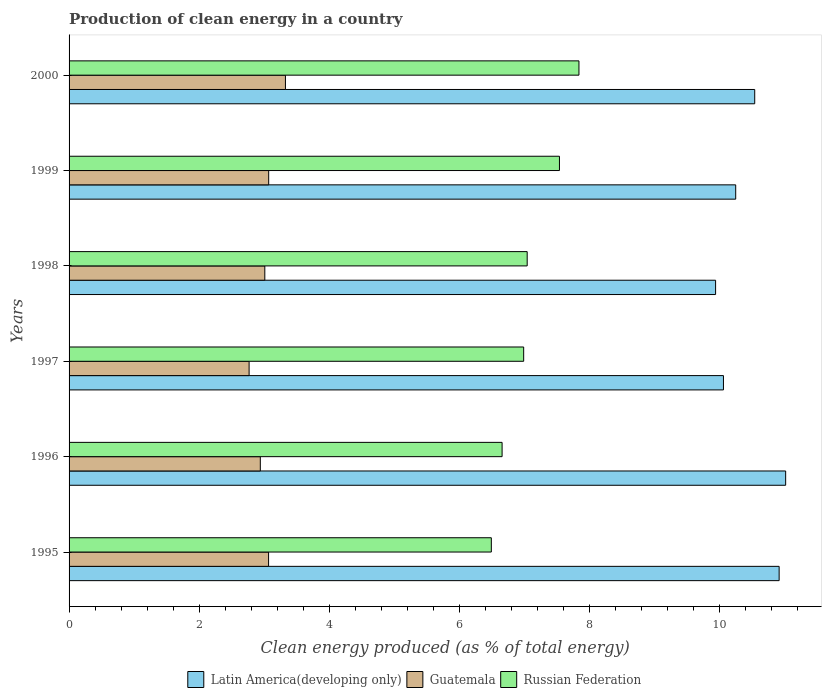How many different coloured bars are there?
Your answer should be very brief. 3. Are the number of bars per tick equal to the number of legend labels?
Make the answer very short. Yes. Are the number of bars on each tick of the Y-axis equal?
Provide a succinct answer. Yes. How many bars are there on the 4th tick from the top?
Keep it short and to the point. 3. In how many cases, is the number of bars for a given year not equal to the number of legend labels?
Your answer should be very brief. 0. What is the percentage of clean energy produced in Guatemala in 1998?
Give a very brief answer. 3.01. Across all years, what is the maximum percentage of clean energy produced in Russian Federation?
Your answer should be compact. 7.84. Across all years, what is the minimum percentage of clean energy produced in Latin America(developing only)?
Keep it short and to the point. 9.95. What is the total percentage of clean energy produced in Russian Federation in the graph?
Make the answer very short. 42.59. What is the difference between the percentage of clean energy produced in Russian Federation in 1996 and that in 2000?
Your answer should be compact. -1.18. What is the difference between the percentage of clean energy produced in Latin America(developing only) in 2000 and the percentage of clean energy produced in Russian Federation in 1995?
Make the answer very short. 4.05. What is the average percentage of clean energy produced in Russian Federation per year?
Make the answer very short. 7.1. In the year 1999, what is the difference between the percentage of clean energy produced in Latin America(developing only) and percentage of clean energy produced in Guatemala?
Make the answer very short. 7.19. In how many years, is the percentage of clean energy produced in Latin America(developing only) greater than 9.6 %?
Give a very brief answer. 6. What is the ratio of the percentage of clean energy produced in Russian Federation in 1998 to that in 2000?
Provide a short and direct response. 0.9. Is the percentage of clean energy produced in Guatemala in 1998 less than that in 1999?
Your answer should be very brief. Yes. What is the difference between the highest and the second highest percentage of clean energy produced in Latin America(developing only)?
Offer a terse response. 0.1. What is the difference between the highest and the lowest percentage of clean energy produced in Latin America(developing only)?
Your answer should be very brief. 1.08. What does the 1st bar from the top in 1997 represents?
Keep it short and to the point. Russian Federation. What does the 1st bar from the bottom in 1996 represents?
Your answer should be very brief. Latin America(developing only). Is it the case that in every year, the sum of the percentage of clean energy produced in Latin America(developing only) and percentage of clean energy produced in Guatemala is greater than the percentage of clean energy produced in Russian Federation?
Your response must be concise. Yes. How many bars are there?
Your answer should be compact. 18. Are all the bars in the graph horizontal?
Provide a succinct answer. Yes. Does the graph contain any zero values?
Your answer should be very brief. No. What is the title of the graph?
Your answer should be very brief. Production of clean energy in a country. What is the label or title of the X-axis?
Make the answer very short. Clean energy produced (as % of total energy). What is the Clean energy produced (as % of total energy) in Latin America(developing only) in 1995?
Provide a succinct answer. 10.92. What is the Clean energy produced (as % of total energy) in Guatemala in 1995?
Your response must be concise. 3.07. What is the Clean energy produced (as % of total energy) of Russian Federation in 1995?
Offer a very short reply. 6.5. What is the Clean energy produced (as % of total energy) of Latin America(developing only) in 1996?
Provide a short and direct response. 11.03. What is the Clean energy produced (as % of total energy) in Guatemala in 1996?
Your response must be concise. 2.94. What is the Clean energy produced (as % of total energy) in Russian Federation in 1996?
Give a very brief answer. 6.66. What is the Clean energy produced (as % of total energy) in Latin America(developing only) in 1997?
Your answer should be compact. 10.07. What is the Clean energy produced (as % of total energy) in Guatemala in 1997?
Provide a short and direct response. 2.77. What is the Clean energy produced (as % of total energy) in Russian Federation in 1997?
Ensure brevity in your answer.  6.99. What is the Clean energy produced (as % of total energy) in Latin America(developing only) in 1998?
Give a very brief answer. 9.95. What is the Clean energy produced (as % of total energy) of Guatemala in 1998?
Provide a succinct answer. 3.01. What is the Clean energy produced (as % of total energy) of Russian Federation in 1998?
Provide a short and direct response. 7.05. What is the Clean energy produced (as % of total energy) of Latin America(developing only) in 1999?
Keep it short and to the point. 10.26. What is the Clean energy produced (as % of total energy) of Guatemala in 1999?
Make the answer very short. 3.07. What is the Clean energy produced (as % of total energy) in Russian Federation in 1999?
Keep it short and to the point. 7.54. What is the Clean energy produced (as % of total energy) of Latin America(developing only) in 2000?
Provide a short and direct response. 10.55. What is the Clean energy produced (as % of total energy) in Guatemala in 2000?
Ensure brevity in your answer.  3.33. What is the Clean energy produced (as % of total energy) in Russian Federation in 2000?
Make the answer very short. 7.84. Across all years, what is the maximum Clean energy produced (as % of total energy) of Latin America(developing only)?
Your answer should be compact. 11.03. Across all years, what is the maximum Clean energy produced (as % of total energy) in Guatemala?
Make the answer very short. 3.33. Across all years, what is the maximum Clean energy produced (as % of total energy) of Russian Federation?
Keep it short and to the point. 7.84. Across all years, what is the minimum Clean energy produced (as % of total energy) in Latin America(developing only)?
Provide a short and direct response. 9.95. Across all years, what is the minimum Clean energy produced (as % of total energy) of Guatemala?
Your answer should be very brief. 2.77. Across all years, what is the minimum Clean energy produced (as % of total energy) in Russian Federation?
Provide a short and direct response. 6.5. What is the total Clean energy produced (as % of total energy) in Latin America(developing only) in the graph?
Keep it short and to the point. 62.77. What is the total Clean energy produced (as % of total energy) in Guatemala in the graph?
Your answer should be compact. 18.19. What is the total Clean energy produced (as % of total energy) in Russian Federation in the graph?
Give a very brief answer. 42.59. What is the difference between the Clean energy produced (as % of total energy) in Latin America(developing only) in 1995 and that in 1996?
Make the answer very short. -0.1. What is the difference between the Clean energy produced (as % of total energy) of Guatemala in 1995 and that in 1996?
Your answer should be very brief. 0.13. What is the difference between the Clean energy produced (as % of total energy) of Russian Federation in 1995 and that in 1996?
Make the answer very short. -0.17. What is the difference between the Clean energy produced (as % of total energy) in Latin America(developing only) in 1995 and that in 1997?
Keep it short and to the point. 0.86. What is the difference between the Clean energy produced (as % of total energy) in Guatemala in 1995 and that in 1997?
Provide a succinct answer. 0.3. What is the difference between the Clean energy produced (as % of total energy) of Russian Federation in 1995 and that in 1997?
Keep it short and to the point. -0.5. What is the difference between the Clean energy produced (as % of total energy) of Latin America(developing only) in 1995 and that in 1998?
Your response must be concise. 0.98. What is the difference between the Clean energy produced (as % of total energy) in Guatemala in 1995 and that in 1998?
Your answer should be compact. 0.06. What is the difference between the Clean energy produced (as % of total energy) in Russian Federation in 1995 and that in 1998?
Provide a succinct answer. -0.55. What is the difference between the Clean energy produced (as % of total energy) in Latin America(developing only) in 1995 and that in 1999?
Your answer should be very brief. 0.67. What is the difference between the Clean energy produced (as % of total energy) in Guatemala in 1995 and that in 1999?
Provide a succinct answer. -0. What is the difference between the Clean energy produced (as % of total energy) in Russian Federation in 1995 and that in 1999?
Keep it short and to the point. -1.05. What is the difference between the Clean energy produced (as % of total energy) of Latin America(developing only) in 1995 and that in 2000?
Keep it short and to the point. 0.38. What is the difference between the Clean energy produced (as % of total energy) of Guatemala in 1995 and that in 2000?
Ensure brevity in your answer.  -0.26. What is the difference between the Clean energy produced (as % of total energy) in Russian Federation in 1995 and that in 2000?
Offer a very short reply. -1.35. What is the difference between the Clean energy produced (as % of total energy) of Latin America(developing only) in 1996 and that in 1997?
Provide a succinct answer. 0.96. What is the difference between the Clean energy produced (as % of total energy) of Guatemala in 1996 and that in 1997?
Ensure brevity in your answer.  0.17. What is the difference between the Clean energy produced (as % of total energy) in Russian Federation in 1996 and that in 1997?
Offer a very short reply. -0.33. What is the difference between the Clean energy produced (as % of total energy) in Latin America(developing only) in 1996 and that in 1998?
Offer a very short reply. 1.08. What is the difference between the Clean energy produced (as % of total energy) in Guatemala in 1996 and that in 1998?
Offer a terse response. -0.07. What is the difference between the Clean energy produced (as % of total energy) in Russian Federation in 1996 and that in 1998?
Keep it short and to the point. -0.39. What is the difference between the Clean energy produced (as % of total energy) in Latin America(developing only) in 1996 and that in 1999?
Your response must be concise. 0.77. What is the difference between the Clean energy produced (as % of total energy) of Guatemala in 1996 and that in 1999?
Your answer should be very brief. -0.13. What is the difference between the Clean energy produced (as % of total energy) of Russian Federation in 1996 and that in 1999?
Offer a terse response. -0.88. What is the difference between the Clean energy produced (as % of total energy) of Latin America(developing only) in 1996 and that in 2000?
Make the answer very short. 0.48. What is the difference between the Clean energy produced (as % of total energy) of Guatemala in 1996 and that in 2000?
Ensure brevity in your answer.  -0.39. What is the difference between the Clean energy produced (as % of total energy) in Russian Federation in 1996 and that in 2000?
Your answer should be very brief. -1.18. What is the difference between the Clean energy produced (as % of total energy) of Latin America(developing only) in 1997 and that in 1998?
Your answer should be compact. 0.12. What is the difference between the Clean energy produced (as % of total energy) in Guatemala in 1997 and that in 1998?
Offer a terse response. -0.24. What is the difference between the Clean energy produced (as % of total energy) of Russian Federation in 1997 and that in 1998?
Offer a very short reply. -0.05. What is the difference between the Clean energy produced (as % of total energy) of Latin America(developing only) in 1997 and that in 1999?
Give a very brief answer. -0.19. What is the difference between the Clean energy produced (as % of total energy) in Guatemala in 1997 and that in 1999?
Make the answer very short. -0.3. What is the difference between the Clean energy produced (as % of total energy) in Russian Federation in 1997 and that in 1999?
Offer a very short reply. -0.55. What is the difference between the Clean energy produced (as % of total energy) in Latin America(developing only) in 1997 and that in 2000?
Offer a very short reply. -0.48. What is the difference between the Clean energy produced (as % of total energy) in Guatemala in 1997 and that in 2000?
Offer a very short reply. -0.56. What is the difference between the Clean energy produced (as % of total energy) in Russian Federation in 1997 and that in 2000?
Offer a terse response. -0.85. What is the difference between the Clean energy produced (as % of total energy) of Latin America(developing only) in 1998 and that in 1999?
Give a very brief answer. -0.31. What is the difference between the Clean energy produced (as % of total energy) in Guatemala in 1998 and that in 1999?
Provide a succinct answer. -0.06. What is the difference between the Clean energy produced (as % of total energy) in Russian Federation in 1998 and that in 1999?
Provide a short and direct response. -0.5. What is the difference between the Clean energy produced (as % of total energy) of Latin America(developing only) in 1998 and that in 2000?
Your answer should be very brief. -0.6. What is the difference between the Clean energy produced (as % of total energy) of Guatemala in 1998 and that in 2000?
Your answer should be compact. -0.32. What is the difference between the Clean energy produced (as % of total energy) of Russian Federation in 1998 and that in 2000?
Your response must be concise. -0.8. What is the difference between the Clean energy produced (as % of total energy) in Latin America(developing only) in 1999 and that in 2000?
Offer a terse response. -0.29. What is the difference between the Clean energy produced (as % of total energy) in Guatemala in 1999 and that in 2000?
Offer a terse response. -0.26. What is the difference between the Clean energy produced (as % of total energy) in Russian Federation in 1999 and that in 2000?
Provide a short and direct response. -0.3. What is the difference between the Clean energy produced (as % of total energy) of Latin America(developing only) in 1995 and the Clean energy produced (as % of total energy) of Guatemala in 1996?
Give a very brief answer. 7.98. What is the difference between the Clean energy produced (as % of total energy) in Latin America(developing only) in 1995 and the Clean energy produced (as % of total energy) in Russian Federation in 1996?
Keep it short and to the point. 4.26. What is the difference between the Clean energy produced (as % of total energy) of Guatemala in 1995 and the Clean energy produced (as % of total energy) of Russian Federation in 1996?
Keep it short and to the point. -3.59. What is the difference between the Clean energy produced (as % of total energy) of Latin America(developing only) in 1995 and the Clean energy produced (as % of total energy) of Guatemala in 1997?
Your response must be concise. 8.15. What is the difference between the Clean energy produced (as % of total energy) of Latin America(developing only) in 1995 and the Clean energy produced (as % of total energy) of Russian Federation in 1997?
Provide a succinct answer. 3.93. What is the difference between the Clean energy produced (as % of total energy) of Guatemala in 1995 and the Clean energy produced (as % of total energy) of Russian Federation in 1997?
Offer a terse response. -3.92. What is the difference between the Clean energy produced (as % of total energy) of Latin America(developing only) in 1995 and the Clean energy produced (as % of total energy) of Guatemala in 1998?
Provide a short and direct response. 7.91. What is the difference between the Clean energy produced (as % of total energy) of Latin America(developing only) in 1995 and the Clean energy produced (as % of total energy) of Russian Federation in 1998?
Ensure brevity in your answer.  3.88. What is the difference between the Clean energy produced (as % of total energy) of Guatemala in 1995 and the Clean energy produced (as % of total energy) of Russian Federation in 1998?
Your answer should be very brief. -3.98. What is the difference between the Clean energy produced (as % of total energy) of Latin America(developing only) in 1995 and the Clean energy produced (as % of total energy) of Guatemala in 1999?
Your answer should be compact. 7.85. What is the difference between the Clean energy produced (as % of total energy) in Latin America(developing only) in 1995 and the Clean energy produced (as % of total energy) in Russian Federation in 1999?
Offer a very short reply. 3.38. What is the difference between the Clean energy produced (as % of total energy) of Guatemala in 1995 and the Clean energy produced (as % of total energy) of Russian Federation in 1999?
Your answer should be compact. -4.48. What is the difference between the Clean energy produced (as % of total energy) in Latin America(developing only) in 1995 and the Clean energy produced (as % of total energy) in Guatemala in 2000?
Provide a short and direct response. 7.6. What is the difference between the Clean energy produced (as % of total energy) of Latin America(developing only) in 1995 and the Clean energy produced (as % of total energy) of Russian Federation in 2000?
Provide a succinct answer. 3.08. What is the difference between the Clean energy produced (as % of total energy) in Guatemala in 1995 and the Clean energy produced (as % of total energy) in Russian Federation in 2000?
Offer a terse response. -4.78. What is the difference between the Clean energy produced (as % of total energy) in Latin America(developing only) in 1996 and the Clean energy produced (as % of total energy) in Guatemala in 1997?
Ensure brevity in your answer.  8.26. What is the difference between the Clean energy produced (as % of total energy) of Latin America(developing only) in 1996 and the Clean energy produced (as % of total energy) of Russian Federation in 1997?
Your answer should be compact. 4.03. What is the difference between the Clean energy produced (as % of total energy) of Guatemala in 1996 and the Clean energy produced (as % of total energy) of Russian Federation in 1997?
Your answer should be very brief. -4.05. What is the difference between the Clean energy produced (as % of total energy) in Latin America(developing only) in 1996 and the Clean energy produced (as % of total energy) in Guatemala in 1998?
Offer a terse response. 8.01. What is the difference between the Clean energy produced (as % of total energy) in Latin America(developing only) in 1996 and the Clean energy produced (as % of total energy) in Russian Federation in 1998?
Provide a short and direct response. 3.98. What is the difference between the Clean energy produced (as % of total energy) in Guatemala in 1996 and the Clean energy produced (as % of total energy) in Russian Federation in 1998?
Give a very brief answer. -4.11. What is the difference between the Clean energy produced (as % of total energy) in Latin America(developing only) in 1996 and the Clean energy produced (as % of total energy) in Guatemala in 1999?
Keep it short and to the point. 7.95. What is the difference between the Clean energy produced (as % of total energy) in Latin America(developing only) in 1996 and the Clean energy produced (as % of total energy) in Russian Federation in 1999?
Offer a terse response. 3.48. What is the difference between the Clean energy produced (as % of total energy) in Guatemala in 1996 and the Clean energy produced (as % of total energy) in Russian Federation in 1999?
Give a very brief answer. -4.6. What is the difference between the Clean energy produced (as % of total energy) in Latin America(developing only) in 1996 and the Clean energy produced (as % of total energy) in Guatemala in 2000?
Offer a terse response. 7.7. What is the difference between the Clean energy produced (as % of total energy) of Latin America(developing only) in 1996 and the Clean energy produced (as % of total energy) of Russian Federation in 2000?
Ensure brevity in your answer.  3.18. What is the difference between the Clean energy produced (as % of total energy) in Guatemala in 1996 and the Clean energy produced (as % of total energy) in Russian Federation in 2000?
Offer a very short reply. -4.9. What is the difference between the Clean energy produced (as % of total energy) of Latin America(developing only) in 1997 and the Clean energy produced (as % of total energy) of Guatemala in 1998?
Give a very brief answer. 7.06. What is the difference between the Clean energy produced (as % of total energy) of Latin America(developing only) in 1997 and the Clean energy produced (as % of total energy) of Russian Federation in 1998?
Ensure brevity in your answer.  3.02. What is the difference between the Clean energy produced (as % of total energy) of Guatemala in 1997 and the Clean energy produced (as % of total energy) of Russian Federation in 1998?
Your answer should be compact. -4.28. What is the difference between the Clean energy produced (as % of total energy) in Latin America(developing only) in 1997 and the Clean energy produced (as % of total energy) in Guatemala in 1999?
Give a very brief answer. 7. What is the difference between the Clean energy produced (as % of total energy) of Latin America(developing only) in 1997 and the Clean energy produced (as % of total energy) of Russian Federation in 1999?
Give a very brief answer. 2.52. What is the difference between the Clean energy produced (as % of total energy) in Guatemala in 1997 and the Clean energy produced (as % of total energy) in Russian Federation in 1999?
Ensure brevity in your answer.  -4.77. What is the difference between the Clean energy produced (as % of total energy) in Latin America(developing only) in 1997 and the Clean energy produced (as % of total energy) in Guatemala in 2000?
Your answer should be compact. 6.74. What is the difference between the Clean energy produced (as % of total energy) in Latin America(developing only) in 1997 and the Clean energy produced (as % of total energy) in Russian Federation in 2000?
Keep it short and to the point. 2.22. What is the difference between the Clean energy produced (as % of total energy) in Guatemala in 1997 and the Clean energy produced (as % of total energy) in Russian Federation in 2000?
Your answer should be compact. -5.07. What is the difference between the Clean energy produced (as % of total energy) of Latin America(developing only) in 1998 and the Clean energy produced (as % of total energy) of Guatemala in 1999?
Ensure brevity in your answer.  6.88. What is the difference between the Clean energy produced (as % of total energy) of Latin America(developing only) in 1998 and the Clean energy produced (as % of total energy) of Russian Federation in 1999?
Provide a succinct answer. 2.4. What is the difference between the Clean energy produced (as % of total energy) in Guatemala in 1998 and the Clean energy produced (as % of total energy) in Russian Federation in 1999?
Give a very brief answer. -4.53. What is the difference between the Clean energy produced (as % of total energy) of Latin America(developing only) in 1998 and the Clean energy produced (as % of total energy) of Guatemala in 2000?
Keep it short and to the point. 6.62. What is the difference between the Clean energy produced (as % of total energy) of Latin America(developing only) in 1998 and the Clean energy produced (as % of total energy) of Russian Federation in 2000?
Your answer should be compact. 2.1. What is the difference between the Clean energy produced (as % of total energy) of Guatemala in 1998 and the Clean energy produced (as % of total energy) of Russian Federation in 2000?
Provide a succinct answer. -4.83. What is the difference between the Clean energy produced (as % of total energy) of Latin America(developing only) in 1999 and the Clean energy produced (as % of total energy) of Guatemala in 2000?
Your response must be concise. 6.93. What is the difference between the Clean energy produced (as % of total energy) in Latin America(developing only) in 1999 and the Clean energy produced (as % of total energy) in Russian Federation in 2000?
Give a very brief answer. 2.41. What is the difference between the Clean energy produced (as % of total energy) in Guatemala in 1999 and the Clean energy produced (as % of total energy) in Russian Federation in 2000?
Ensure brevity in your answer.  -4.77. What is the average Clean energy produced (as % of total energy) in Latin America(developing only) per year?
Your answer should be very brief. 10.46. What is the average Clean energy produced (as % of total energy) of Guatemala per year?
Give a very brief answer. 3.03. What is the average Clean energy produced (as % of total energy) in Russian Federation per year?
Provide a short and direct response. 7.1. In the year 1995, what is the difference between the Clean energy produced (as % of total energy) of Latin America(developing only) and Clean energy produced (as % of total energy) of Guatemala?
Ensure brevity in your answer.  7.86. In the year 1995, what is the difference between the Clean energy produced (as % of total energy) in Latin America(developing only) and Clean energy produced (as % of total energy) in Russian Federation?
Offer a very short reply. 4.43. In the year 1995, what is the difference between the Clean energy produced (as % of total energy) in Guatemala and Clean energy produced (as % of total energy) in Russian Federation?
Offer a very short reply. -3.43. In the year 1996, what is the difference between the Clean energy produced (as % of total energy) in Latin America(developing only) and Clean energy produced (as % of total energy) in Guatemala?
Give a very brief answer. 8.08. In the year 1996, what is the difference between the Clean energy produced (as % of total energy) of Latin America(developing only) and Clean energy produced (as % of total energy) of Russian Federation?
Offer a very short reply. 4.36. In the year 1996, what is the difference between the Clean energy produced (as % of total energy) in Guatemala and Clean energy produced (as % of total energy) in Russian Federation?
Offer a very short reply. -3.72. In the year 1997, what is the difference between the Clean energy produced (as % of total energy) in Latin America(developing only) and Clean energy produced (as % of total energy) in Guatemala?
Keep it short and to the point. 7.3. In the year 1997, what is the difference between the Clean energy produced (as % of total energy) of Latin America(developing only) and Clean energy produced (as % of total energy) of Russian Federation?
Ensure brevity in your answer.  3.07. In the year 1997, what is the difference between the Clean energy produced (as % of total energy) of Guatemala and Clean energy produced (as % of total energy) of Russian Federation?
Your answer should be very brief. -4.22. In the year 1998, what is the difference between the Clean energy produced (as % of total energy) of Latin America(developing only) and Clean energy produced (as % of total energy) of Guatemala?
Provide a short and direct response. 6.94. In the year 1998, what is the difference between the Clean energy produced (as % of total energy) in Latin America(developing only) and Clean energy produced (as % of total energy) in Russian Federation?
Provide a short and direct response. 2.9. In the year 1998, what is the difference between the Clean energy produced (as % of total energy) of Guatemala and Clean energy produced (as % of total energy) of Russian Federation?
Your answer should be compact. -4.04. In the year 1999, what is the difference between the Clean energy produced (as % of total energy) of Latin America(developing only) and Clean energy produced (as % of total energy) of Guatemala?
Make the answer very short. 7.18. In the year 1999, what is the difference between the Clean energy produced (as % of total energy) in Latin America(developing only) and Clean energy produced (as % of total energy) in Russian Federation?
Make the answer very short. 2.71. In the year 1999, what is the difference between the Clean energy produced (as % of total energy) of Guatemala and Clean energy produced (as % of total energy) of Russian Federation?
Provide a succinct answer. -4.47. In the year 2000, what is the difference between the Clean energy produced (as % of total energy) of Latin America(developing only) and Clean energy produced (as % of total energy) of Guatemala?
Offer a very short reply. 7.22. In the year 2000, what is the difference between the Clean energy produced (as % of total energy) of Latin America(developing only) and Clean energy produced (as % of total energy) of Russian Federation?
Your response must be concise. 2.7. In the year 2000, what is the difference between the Clean energy produced (as % of total energy) of Guatemala and Clean energy produced (as % of total energy) of Russian Federation?
Your answer should be compact. -4.52. What is the ratio of the Clean energy produced (as % of total energy) of Latin America(developing only) in 1995 to that in 1996?
Make the answer very short. 0.99. What is the ratio of the Clean energy produced (as % of total energy) in Guatemala in 1995 to that in 1996?
Make the answer very short. 1.04. What is the ratio of the Clean energy produced (as % of total energy) of Russian Federation in 1995 to that in 1996?
Keep it short and to the point. 0.98. What is the ratio of the Clean energy produced (as % of total energy) in Latin America(developing only) in 1995 to that in 1997?
Provide a short and direct response. 1.09. What is the ratio of the Clean energy produced (as % of total energy) in Guatemala in 1995 to that in 1997?
Make the answer very short. 1.11. What is the ratio of the Clean energy produced (as % of total energy) in Russian Federation in 1995 to that in 1997?
Ensure brevity in your answer.  0.93. What is the ratio of the Clean energy produced (as % of total energy) in Latin America(developing only) in 1995 to that in 1998?
Your answer should be compact. 1.1. What is the ratio of the Clean energy produced (as % of total energy) in Guatemala in 1995 to that in 1998?
Your answer should be compact. 1.02. What is the ratio of the Clean energy produced (as % of total energy) in Russian Federation in 1995 to that in 1998?
Provide a succinct answer. 0.92. What is the ratio of the Clean energy produced (as % of total energy) in Latin America(developing only) in 1995 to that in 1999?
Your answer should be compact. 1.07. What is the ratio of the Clean energy produced (as % of total energy) in Guatemala in 1995 to that in 1999?
Keep it short and to the point. 1. What is the ratio of the Clean energy produced (as % of total energy) in Russian Federation in 1995 to that in 1999?
Your response must be concise. 0.86. What is the ratio of the Clean energy produced (as % of total energy) in Latin America(developing only) in 1995 to that in 2000?
Your answer should be compact. 1.04. What is the ratio of the Clean energy produced (as % of total energy) of Guatemala in 1995 to that in 2000?
Offer a terse response. 0.92. What is the ratio of the Clean energy produced (as % of total energy) of Russian Federation in 1995 to that in 2000?
Make the answer very short. 0.83. What is the ratio of the Clean energy produced (as % of total energy) in Latin America(developing only) in 1996 to that in 1997?
Offer a terse response. 1.1. What is the ratio of the Clean energy produced (as % of total energy) in Guatemala in 1996 to that in 1997?
Make the answer very short. 1.06. What is the ratio of the Clean energy produced (as % of total energy) of Russian Federation in 1996 to that in 1997?
Your response must be concise. 0.95. What is the ratio of the Clean energy produced (as % of total energy) of Latin America(developing only) in 1996 to that in 1998?
Offer a very short reply. 1.11. What is the ratio of the Clean energy produced (as % of total energy) in Guatemala in 1996 to that in 1998?
Offer a terse response. 0.98. What is the ratio of the Clean energy produced (as % of total energy) in Russian Federation in 1996 to that in 1998?
Your response must be concise. 0.95. What is the ratio of the Clean energy produced (as % of total energy) in Latin America(developing only) in 1996 to that in 1999?
Provide a short and direct response. 1.07. What is the ratio of the Clean energy produced (as % of total energy) in Guatemala in 1996 to that in 1999?
Give a very brief answer. 0.96. What is the ratio of the Clean energy produced (as % of total energy) of Russian Federation in 1996 to that in 1999?
Your answer should be very brief. 0.88. What is the ratio of the Clean energy produced (as % of total energy) of Latin America(developing only) in 1996 to that in 2000?
Keep it short and to the point. 1.05. What is the ratio of the Clean energy produced (as % of total energy) of Guatemala in 1996 to that in 2000?
Provide a short and direct response. 0.88. What is the ratio of the Clean energy produced (as % of total energy) of Russian Federation in 1996 to that in 2000?
Make the answer very short. 0.85. What is the ratio of the Clean energy produced (as % of total energy) in Latin America(developing only) in 1997 to that in 1998?
Give a very brief answer. 1.01. What is the ratio of the Clean energy produced (as % of total energy) of Guatemala in 1997 to that in 1998?
Ensure brevity in your answer.  0.92. What is the ratio of the Clean energy produced (as % of total energy) in Russian Federation in 1997 to that in 1998?
Your response must be concise. 0.99. What is the ratio of the Clean energy produced (as % of total energy) in Latin America(developing only) in 1997 to that in 1999?
Give a very brief answer. 0.98. What is the ratio of the Clean energy produced (as % of total energy) in Guatemala in 1997 to that in 1999?
Provide a succinct answer. 0.9. What is the ratio of the Clean energy produced (as % of total energy) in Russian Federation in 1997 to that in 1999?
Your answer should be very brief. 0.93. What is the ratio of the Clean energy produced (as % of total energy) in Latin America(developing only) in 1997 to that in 2000?
Keep it short and to the point. 0.95. What is the ratio of the Clean energy produced (as % of total energy) of Guatemala in 1997 to that in 2000?
Your answer should be compact. 0.83. What is the ratio of the Clean energy produced (as % of total energy) of Russian Federation in 1997 to that in 2000?
Your answer should be compact. 0.89. What is the ratio of the Clean energy produced (as % of total energy) of Latin America(developing only) in 1998 to that in 1999?
Your answer should be compact. 0.97. What is the ratio of the Clean energy produced (as % of total energy) of Guatemala in 1998 to that in 1999?
Provide a succinct answer. 0.98. What is the ratio of the Clean energy produced (as % of total energy) in Russian Federation in 1998 to that in 1999?
Your response must be concise. 0.93. What is the ratio of the Clean energy produced (as % of total energy) in Latin America(developing only) in 1998 to that in 2000?
Ensure brevity in your answer.  0.94. What is the ratio of the Clean energy produced (as % of total energy) in Guatemala in 1998 to that in 2000?
Offer a very short reply. 0.9. What is the ratio of the Clean energy produced (as % of total energy) in Russian Federation in 1998 to that in 2000?
Your response must be concise. 0.9. What is the ratio of the Clean energy produced (as % of total energy) of Latin America(developing only) in 1999 to that in 2000?
Make the answer very short. 0.97. What is the ratio of the Clean energy produced (as % of total energy) of Guatemala in 1999 to that in 2000?
Your answer should be compact. 0.92. What is the ratio of the Clean energy produced (as % of total energy) of Russian Federation in 1999 to that in 2000?
Offer a very short reply. 0.96. What is the difference between the highest and the second highest Clean energy produced (as % of total energy) of Latin America(developing only)?
Provide a short and direct response. 0.1. What is the difference between the highest and the second highest Clean energy produced (as % of total energy) of Guatemala?
Give a very brief answer. 0.26. What is the difference between the highest and the second highest Clean energy produced (as % of total energy) of Russian Federation?
Provide a short and direct response. 0.3. What is the difference between the highest and the lowest Clean energy produced (as % of total energy) in Latin America(developing only)?
Your response must be concise. 1.08. What is the difference between the highest and the lowest Clean energy produced (as % of total energy) of Guatemala?
Offer a very short reply. 0.56. What is the difference between the highest and the lowest Clean energy produced (as % of total energy) of Russian Federation?
Your response must be concise. 1.35. 